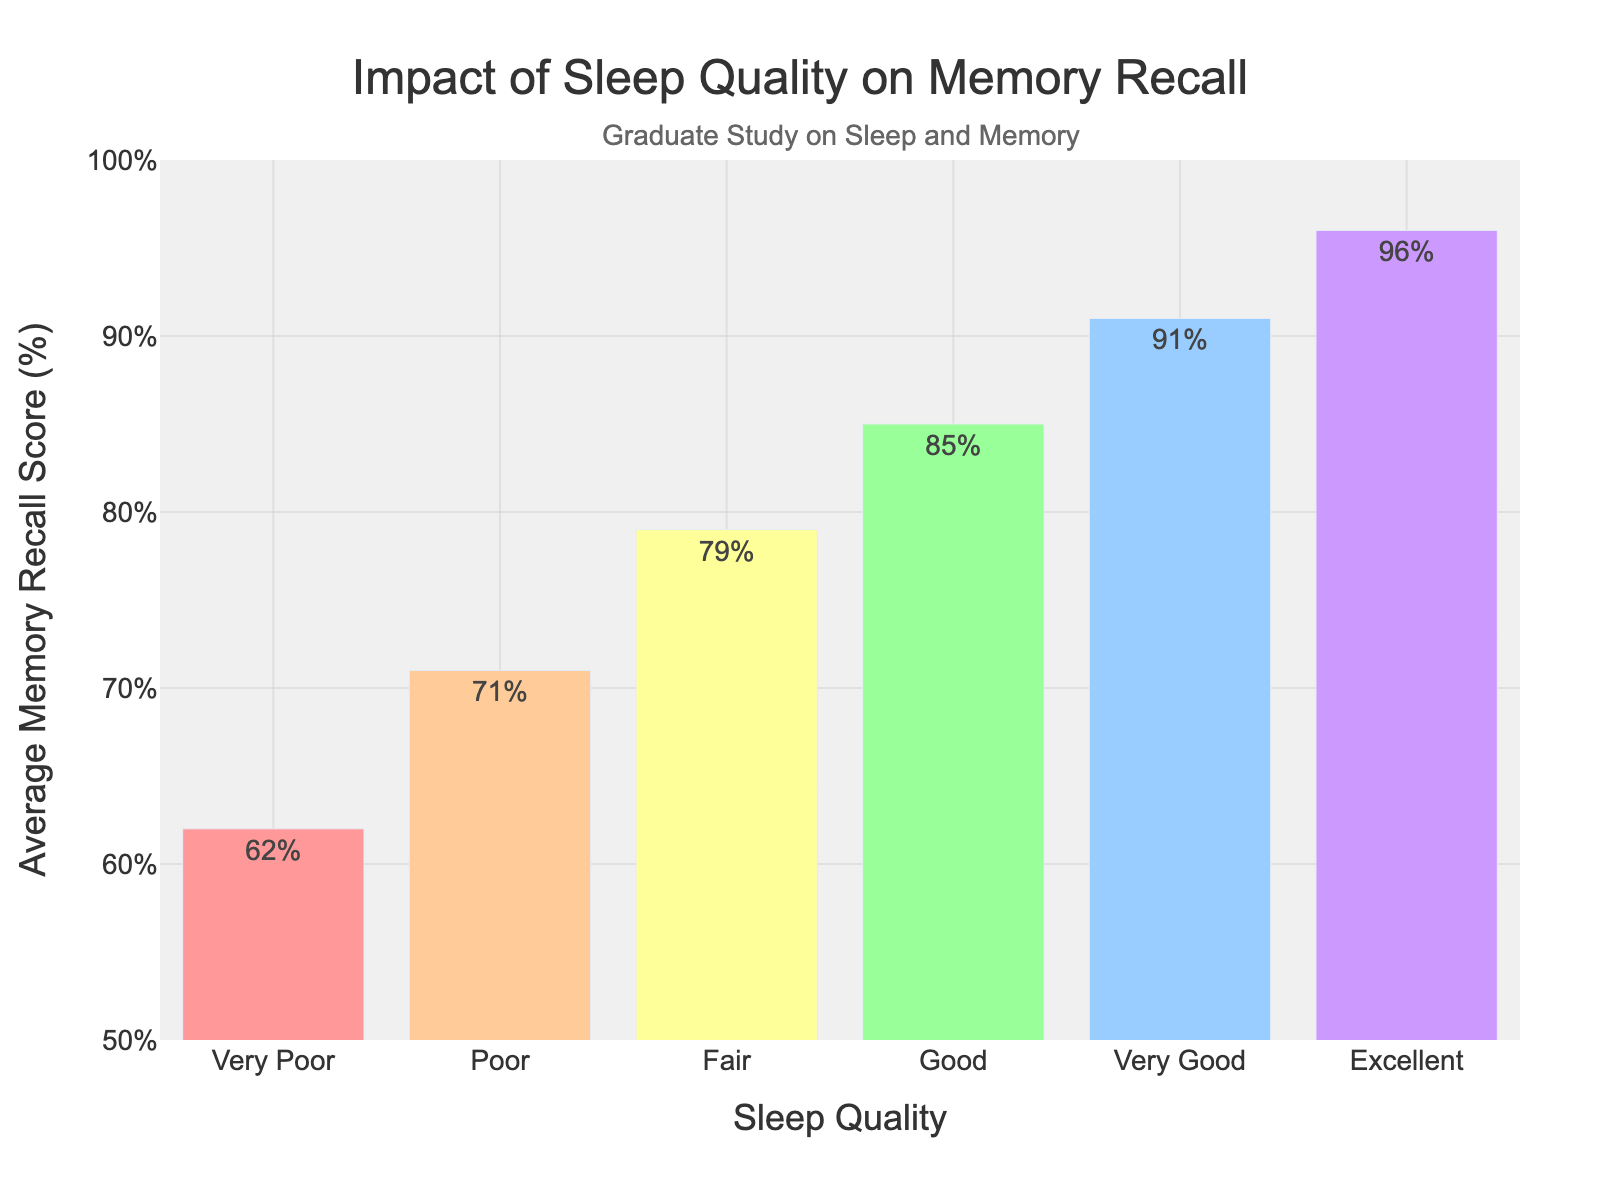How does the average memory recall score for 'Excellent' sleep quality compare to 'Very Poor' sleep quality? The average memory recall score for 'Excellent' sleep quality is 96%, while for 'Very Poor' sleep quality it is 62%. Comparing these two values directly, 'Excellent' sleep quality has a higher average memory recall score than 'Very Poor'.
Answer: 'Excellent' sleep quality has a higher score What is the difference in average memory recall score between 'Good' sleep quality and 'Poor' sleep quality? The average memory recall score for 'Good' sleep quality is 85% and for 'Poor' sleep quality is 71%. Subtracting the latter from the former gives 85% - 71% = 14%.
Answer: 14% Which sleep quality level has the lowest average memory recall score? Looking at all the sleep quality levels, 'Very Poor' has the lowest average memory recall score at 62%.
Answer: Very Poor What's the median value of the average memory recall scores across all sleep quality levels? First, list all the scores in ascending order: 62, 71, 79, 85, 91, 96. The median value is the average of the two middle numbers (79 and 85), which is (79 + 85) / 2 = 82%.
Answer: 82% What percentage difference is there between 'Fair' and 'Very Good' sleep quality levels in terms of average memory recall score? 'Fair' sleep quality has an average memory recall score of 79% and 'Very Good' has 91%. The percentage difference is calculated as ((91 - 79) / 79) * 100% ≈ 15.19%.
Answer: ~15.19% What trend can be observed from the chart with respect to sleep quality and memory recall score? From 'Very Poor' to 'Excellent' sleep quality, there is a clear increasing trend in the average memory recall scores, indicating that better sleep quality is associated with higher memory recall performance.
Answer: Increasing trend Which sleep quality levels fall below the 80% mark in average memory recall score? The sleep quality levels 'Very Poor' (62%) and 'Poor' (71%) fall below the 80% mark in average memory recall score.
Answer: Very Poor, Poor How much higher is the memory recall score for 'Very Good' sleep quality compared to 'Fair' sleep quality? The average memory recall score for 'Very Good' sleep quality is 91%, and for 'Fair' sleep quality, it is 79%. The difference is 91% - 79% = 12%.
Answer: 12% Identify the two sleep quality levels with the closest average memory recall scores. What is their difference? The closest average memory recall scores are 'Poor' (71%) and 'Fair' (79%) with a difference of 79% - 71% = 8%.
Answer: Poor and Fair, 8% How does the color of the bars represent the varying sleep quality levels in the chart? The colors progress from a lighter to darker gradient, transitioning through different shades such as red, orange, yellow, green, blue, and purple as the sleep quality level improves from 'Very Poor' to 'Excellent'.
Answer: Gradient from red to purple 